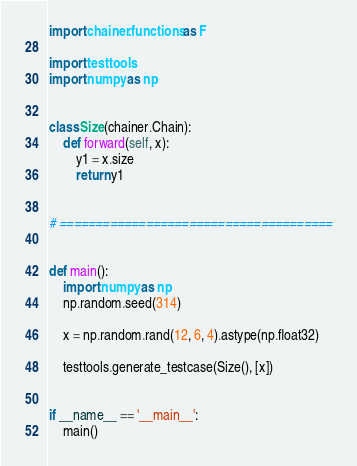<code> <loc_0><loc_0><loc_500><loc_500><_Python_>import chainer.functions as F

import testtools
import numpy as np


class Size(chainer.Chain):
    def forward(self, x):
        y1 = x.size
        return y1


# ======================================


def main():
    import numpy as np
    np.random.seed(314)

    x = np.random.rand(12, 6, 4).astype(np.float32)

    testtools.generate_testcase(Size(), [x])


if __name__ == '__main__':
    main()
</code> 